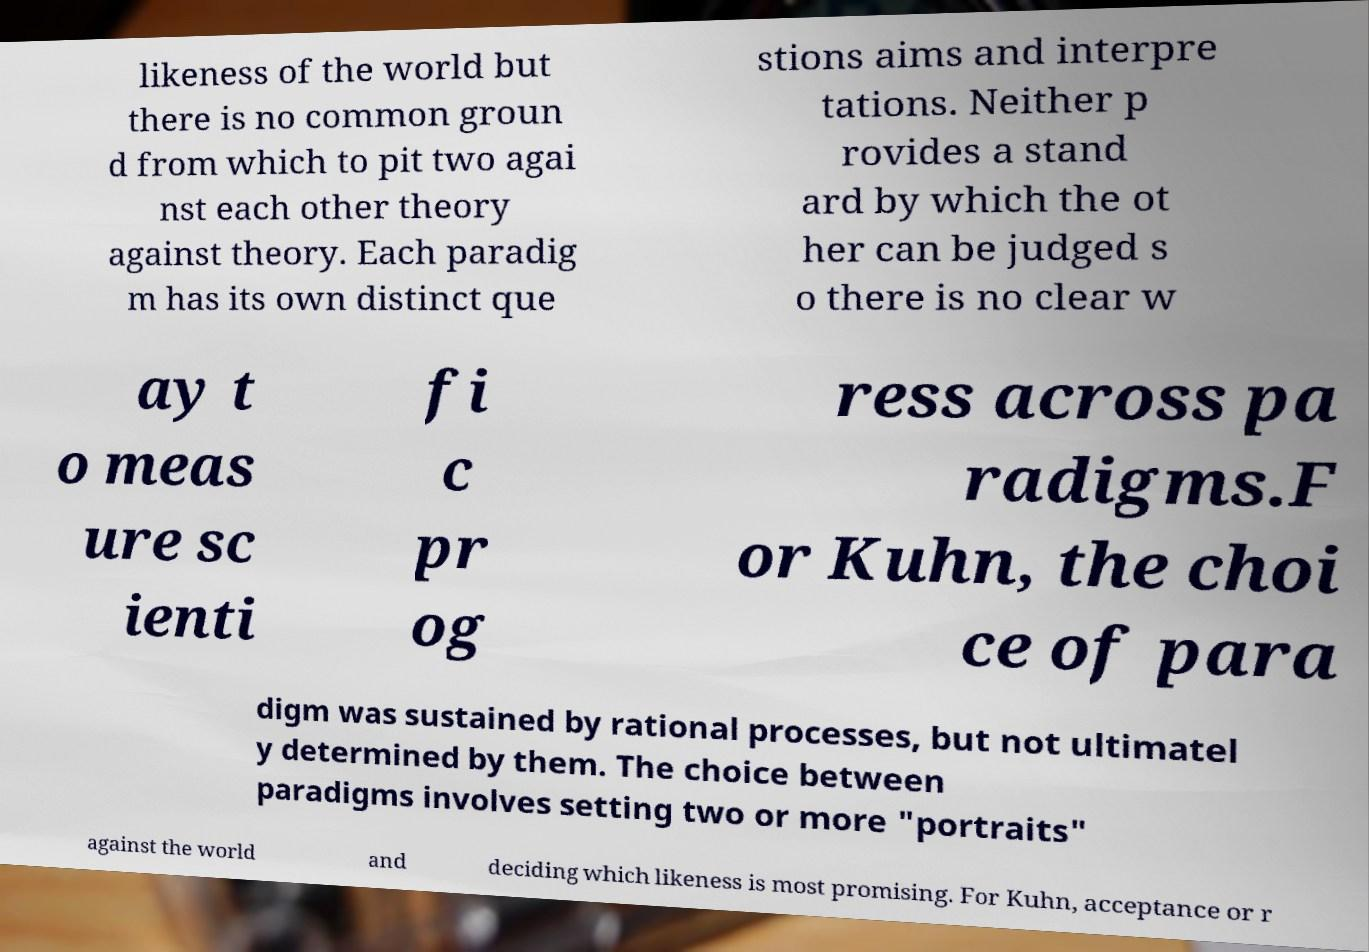Please read and relay the text visible in this image. What does it say? likeness of the world but there is no common groun d from which to pit two agai nst each other theory against theory. Each paradig m has its own distinct que stions aims and interpre tations. Neither p rovides a stand ard by which the ot her can be judged s o there is no clear w ay t o meas ure sc ienti fi c pr og ress across pa radigms.F or Kuhn, the choi ce of para digm was sustained by rational processes, but not ultimatel y determined by them. The choice between paradigms involves setting two or more "portraits" against the world and deciding which likeness is most promising. For Kuhn, acceptance or r 